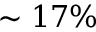<formula> <loc_0><loc_0><loc_500><loc_500>\sim 1 7 \%</formula> 